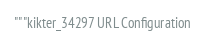<code> <loc_0><loc_0><loc_500><loc_500><_Python_>"""kikter_34297 URL Configuration
</code> 